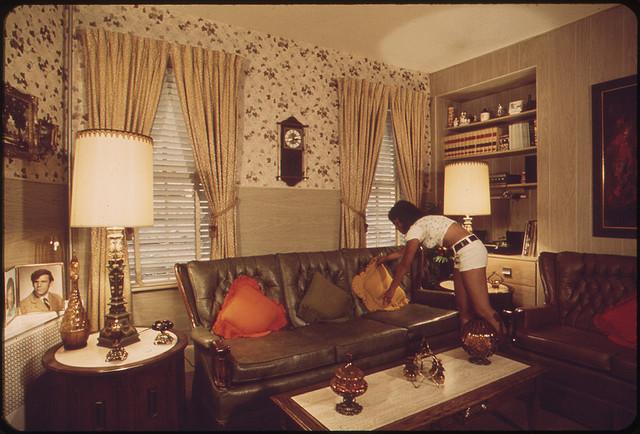What type of pants is the woman wearing?
Give a very brief answer. Shorts. What holiday was the picture taken during?
Write a very short answer. Thanksgiving. What era does this photo capture?
Keep it brief. 70's. Are the cushions on the sofa all the same shape?
Answer briefly. Yes. Is the woman real or a reflection?
Be succinct. Real. 